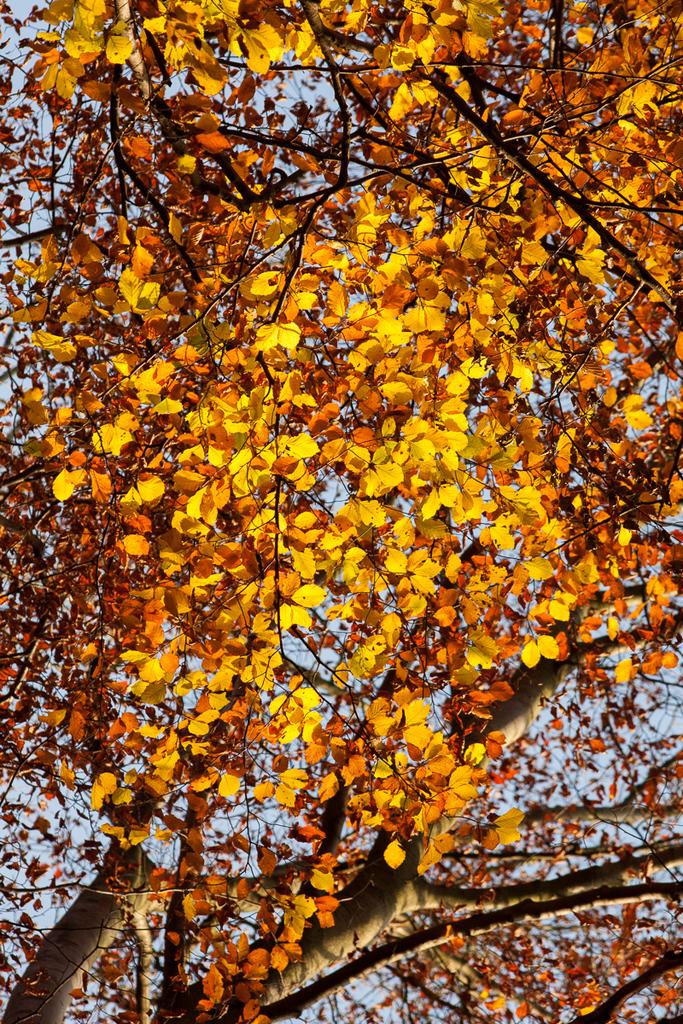What type of vegetation can be seen in the image? There are trees in the image. What part of the natural environment is visible in the image? The sky is visible in the background of the image. What type of rice is being cooked in the stew in the image? There is no rice or stew present in the image; it only features trees and the sky. 